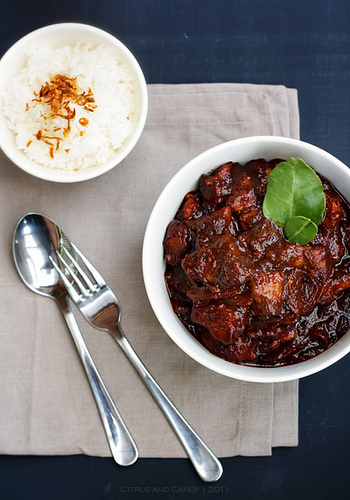<image>
Is the rice in the bowl? No. The rice is not contained within the bowl. These objects have a different spatial relationship. 